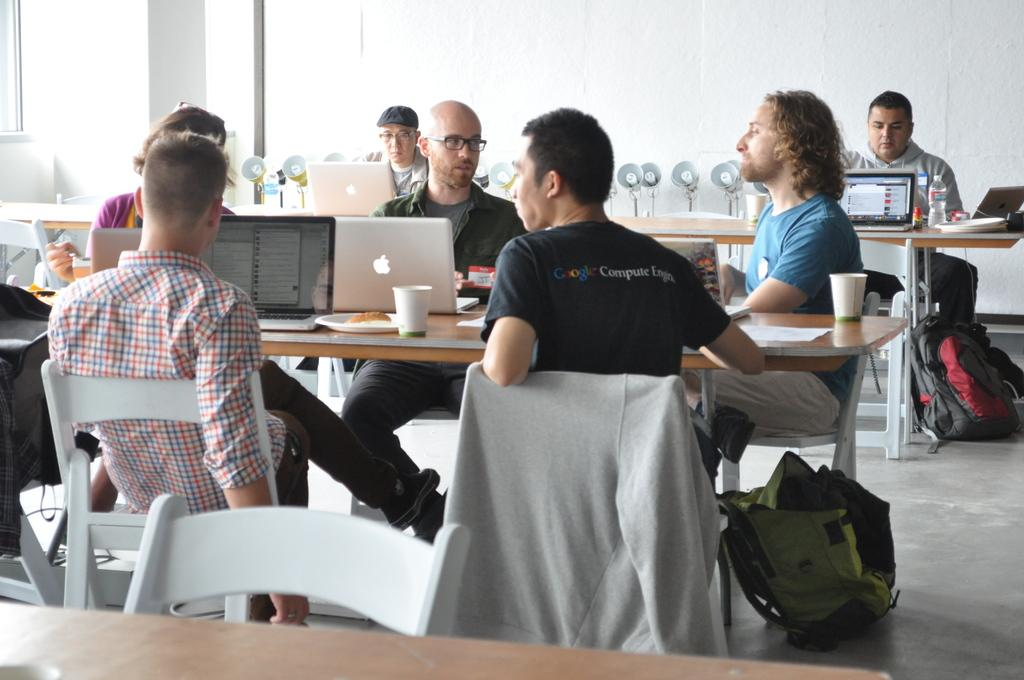Provide a one-sentence caption for the provided image. A man sitting at a table with several other people wears a shirt which reads Google Computer Engine. 